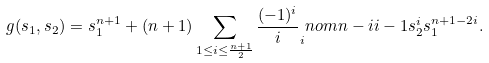<formula> <loc_0><loc_0><loc_500><loc_500>g ( s _ { 1 } , s _ { 2 } ) = s _ { 1 } ^ { n + 1 } + ( n + 1 ) \sum _ { 1 \leq i \leq \frac { n + 1 } { 2 } } \frac { ( - 1 ) ^ { i } } { i } _ { i } n o m { n - i } { i - 1 } s _ { 2 } ^ { i } s _ { 1 } ^ { n + 1 - 2 i } .</formula> 